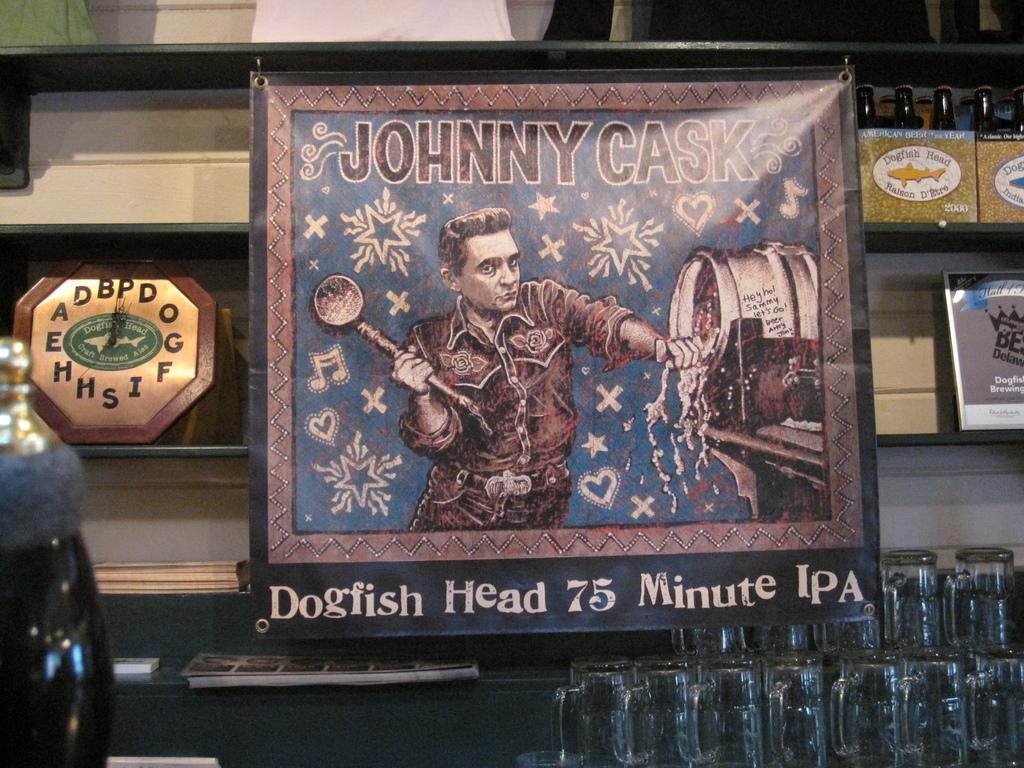Provide a one-sentence caption for the provided image. A bar displays beer mugs under a Johnny Cask brand beer banner. 